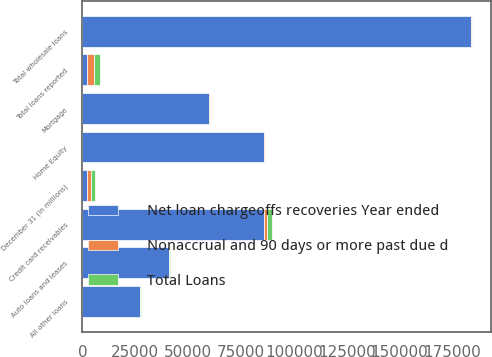Convert chart to OTSL. <chart><loc_0><loc_0><loc_500><loc_500><stacked_bar_chart><ecel><fcel>December 31 (in millions)<fcel>Home Equity<fcel>Mortgage<fcel>Auto loans and leases<fcel>All other loans<fcel>Credit card receivables<fcel>Total wholesale loans<fcel>Total loans reported<nl><fcel>Net loan chargeoffs recoveries Year ended<fcel>2006<fcel>85730<fcel>59668<fcel>41009<fcel>27097<fcel>85881<fcel>183742<fcel>2006<nl><fcel>Nonaccrual and 90 days or more past due d<fcel>2006<fcel>454<fcel>769<fcel>132<fcel>322<fcel>1344<fcel>420<fcel>3441<nl><fcel>Total Loans<fcel>2006<fcel>143<fcel>56<fcel>238<fcel>139<fcel>2488<fcel>22<fcel>3042<nl></chart> 